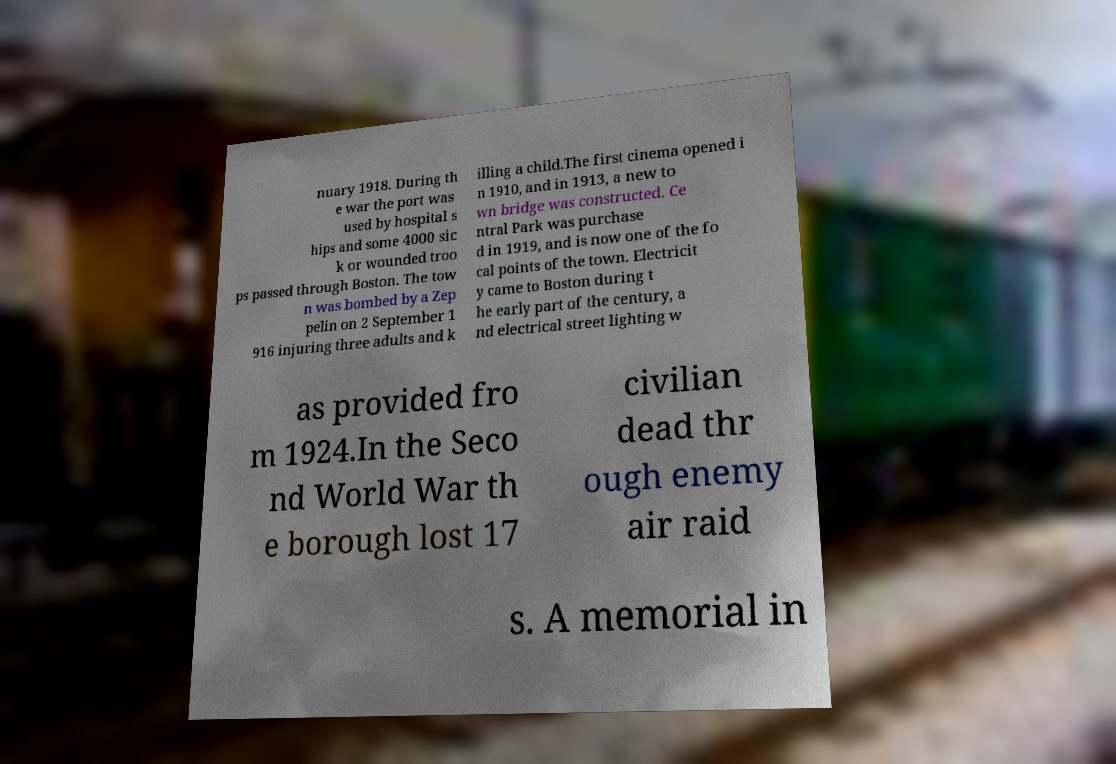Please identify and transcribe the text found in this image. nuary 1918. During th e war the port was used by hospital s hips and some 4000 sic k or wounded troo ps passed through Boston. The tow n was bombed by a Zep pelin on 2 September 1 916 injuring three adults and k illing a child.The first cinema opened i n 1910, and in 1913, a new to wn bridge was constructed. Ce ntral Park was purchase d in 1919, and is now one of the fo cal points of the town. Electricit y came to Boston during t he early part of the century, a nd electrical street lighting w as provided fro m 1924.In the Seco nd World War th e borough lost 17 civilian dead thr ough enemy air raid s. A memorial in 